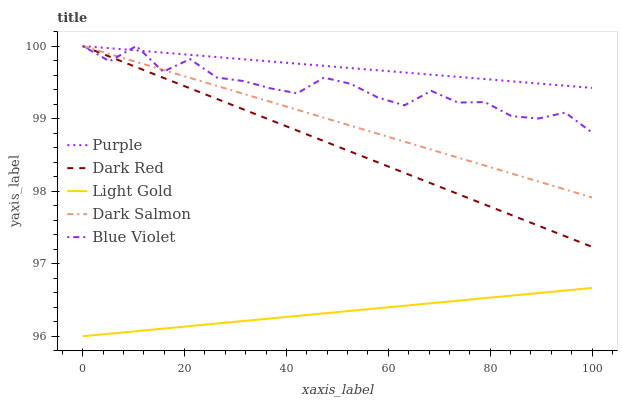Does Light Gold have the minimum area under the curve?
Answer yes or no. Yes. Does Purple have the maximum area under the curve?
Answer yes or no. Yes. Does Dark Red have the minimum area under the curve?
Answer yes or no. No. Does Dark Red have the maximum area under the curve?
Answer yes or no. No. Is Purple the smoothest?
Answer yes or no. Yes. Is Blue Violet the roughest?
Answer yes or no. Yes. Is Dark Red the smoothest?
Answer yes or no. No. Is Dark Red the roughest?
Answer yes or no. No. Does Light Gold have the lowest value?
Answer yes or no. Yes. Does Dark Red have the lowest value?
Answer yes or no. No. Does Blue Violet have the highest value?
Answer yes or no. Yes. Does Light Gold have the highest value?
Answer yes or no. No. Is Light Gold less than Purple?
Answer yes or no. Yes. Is Purple greater than Light Gold?
Answer yes or no. Yes. Does Purple intersect Dark Salmon?
Answer yes or no. Yes. Is Purple less than Dark Salmon?
Answer yes or no. No. Is Purple greater than Dark Salmon?
Answer yes or no. No. Does Light Gold intersect Purple?
Answer yes or no. No. 